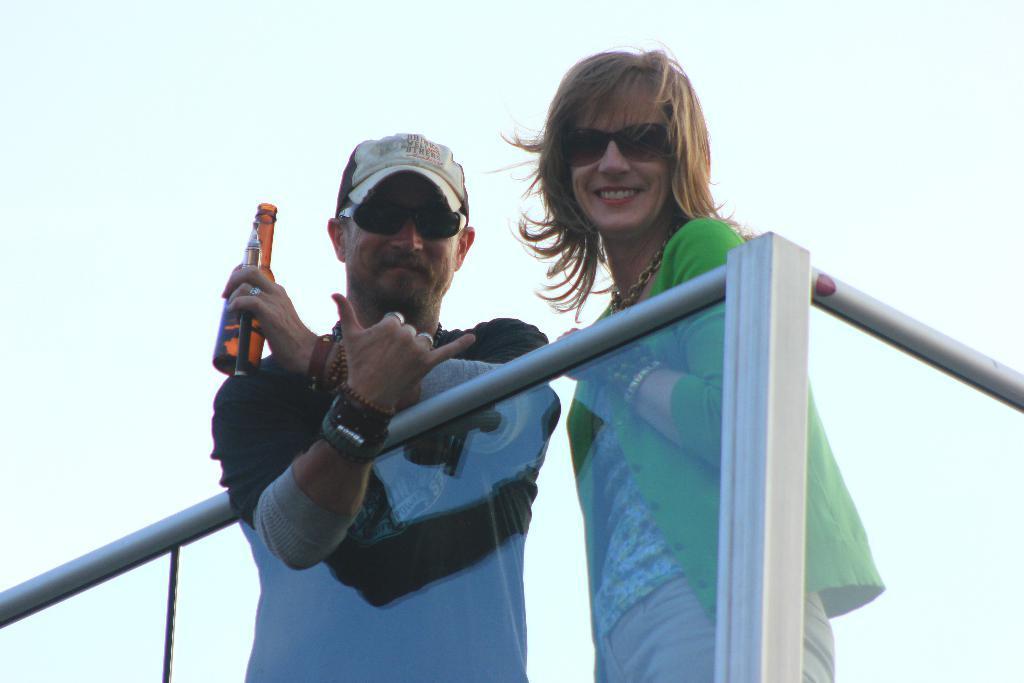Could you give a brief overview of what you see in this image? In this picture we can see railing, two people wore goggles, smiling, standing and a man holding a bottle with his hand. In the background we can see the sky. 